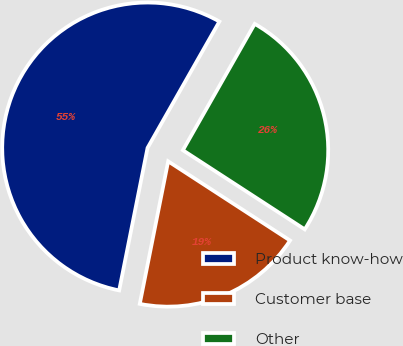<chart> <loc_0><loc_0><loc_500><loc_500><pie_chart><fcel>Product know-how<fcel>Customer base<fcel>Other<nl><fcel>55.1%<fcel>18.96%<fcel>25.94%<nl></chart> 